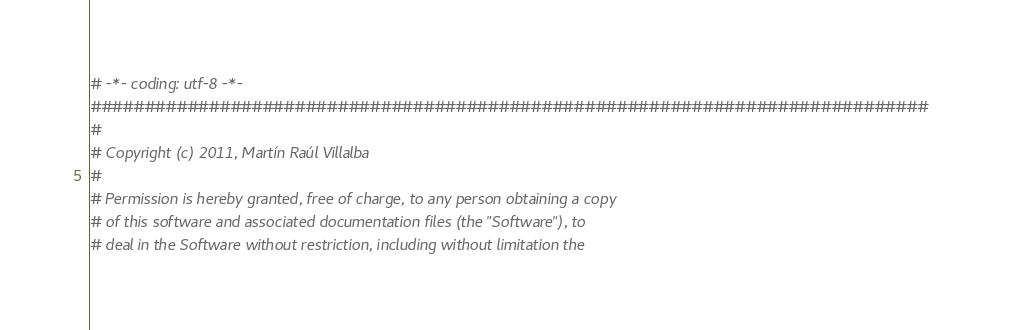Convert code to text. <code><loc_0><loc_0><loc_500><loc_500><_Python_># -*- coding: utf-8 -*-
##############################################################################
#
# Copyright (c) 2011, Martín Raúl Villalba
#
# Permission is hereby granted, free of charge, to any person obtaining a copy
# of this software and associated documentation files (the "Software"), to
# deal in the Software without restriction, including without limitation the</code> 